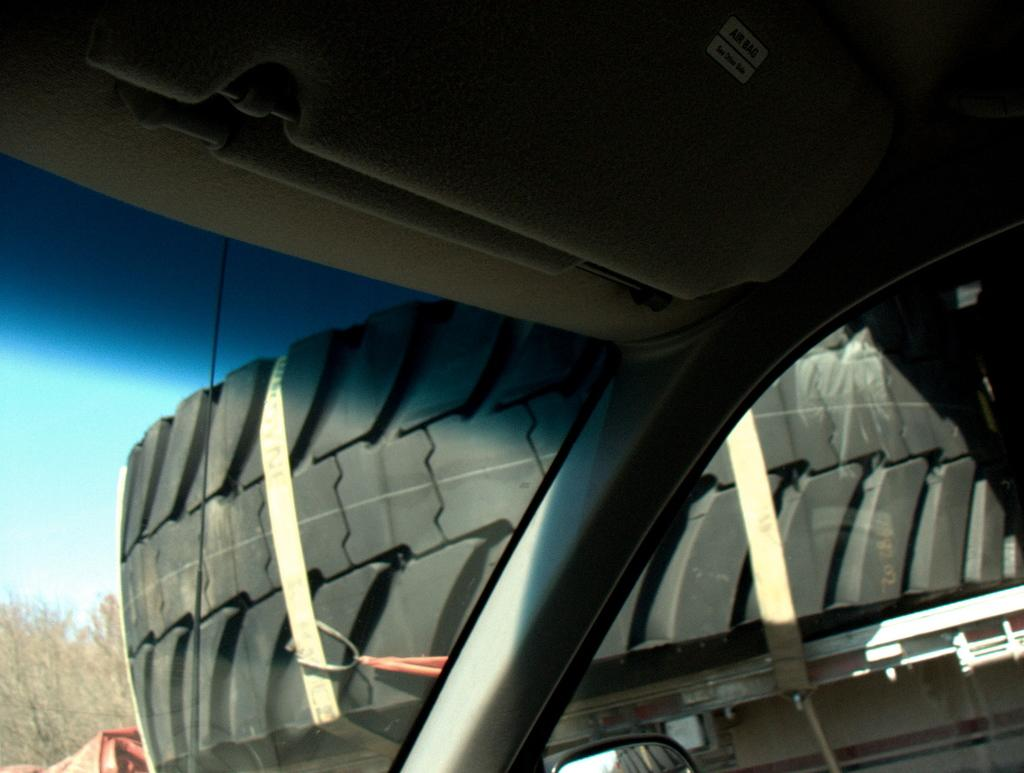What is the main subject in the front of the image? There is a car in the front of the image. What object is located in the center of the image? There is a tire in the center of the image. What type of natural scenery can be seen in the background of the image? There are trees in the background of the image. Can you describe the red object in the background of the image? There is an object that is red in color in the background of the image. What trick does the car perform in the image? The car does not perform any tricks in the image; it is simply parked or stationary. 